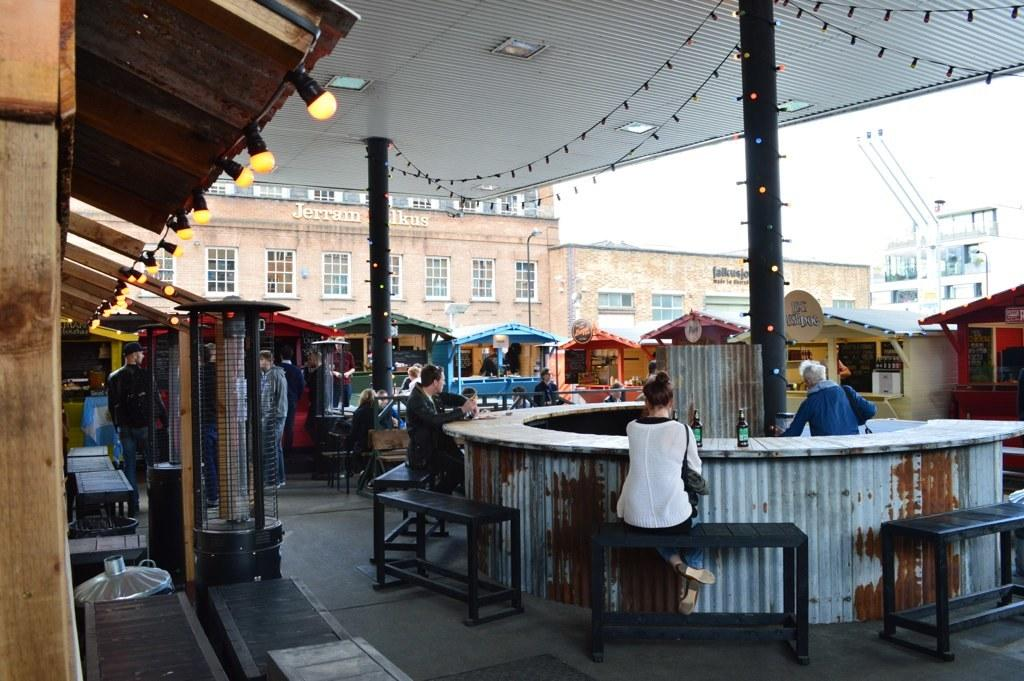How many people are standing on the left side of the image? There are three people standing on the left side of the image. What are the other people in the image doing? There are two people sitting on chairs in the image. What type of structures can be seen in the image? There are buildings visible in the image. What is visible above the structures and people? The sky is visible in the image. What type of transport can be seen in the image? There is no transport visible in the image. What order are the people arranged in the image? The people in the image are not arranged in any specific order; they are standing and sitting in various positions. 